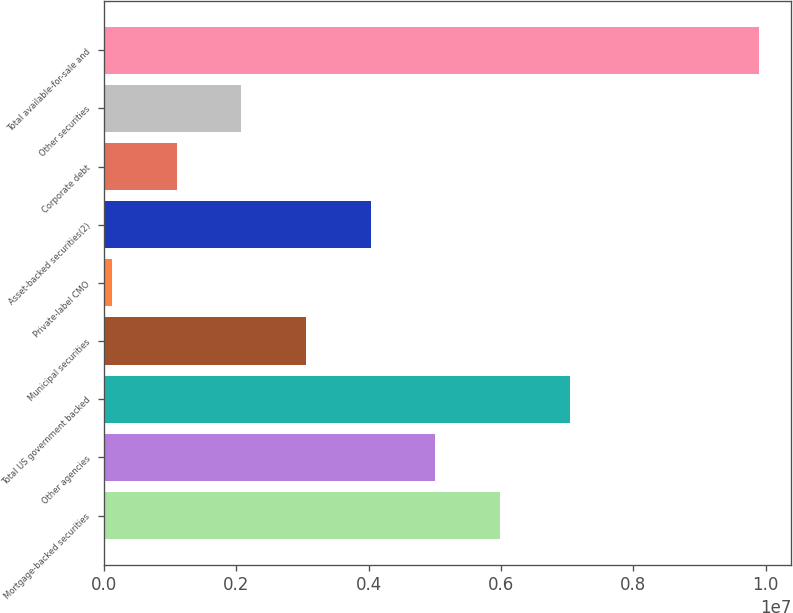Convert chart to OTSL. <chart><loc_0><loc_0><loc_500><loc_500><bar_chart><fcel>Mortgage-backed securities<fcel>Other agencies<fcel>Total US government backed<fcel>Municipal securities<fcel>Private-label CMO<fcel>Asset-backed securities(2)<fcel>Corporate debt<fcel>Other securities<fcel>Total available-for-sale and<nl><fcel>5.98592e+06<fcel>5.00858e+06<fcel>7.04803e+06<fcel>3.05392e+06<fcel>121925<fcel>4.03125e+06<fcel>1.09926e+06<fcel>2.07659e+06<fcel>9.89524e+06<nl></chart> 